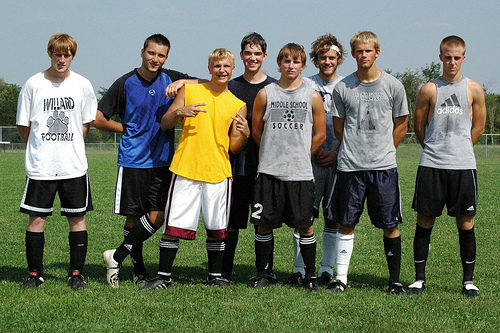<image>
Can you confirm if the boy is behind the boy? Yes. From this viewpoint, the boy is positioned behind the boy, with the boy partially or fully occluding the boy. 